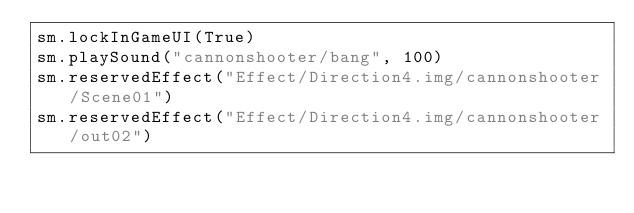<code> <loc_0><loc_0><loc_500><loc_500><_Python_>sm.lockInGameUI(True)
sm.playSound("cannonshooter/bang", 100)
sm.reservedEffect("Effect/Direction4.img/cannonshooter/Scene01")
sm.reservedEffect("Effect/Direction4.img/cannonshooter/out02")
</code> 